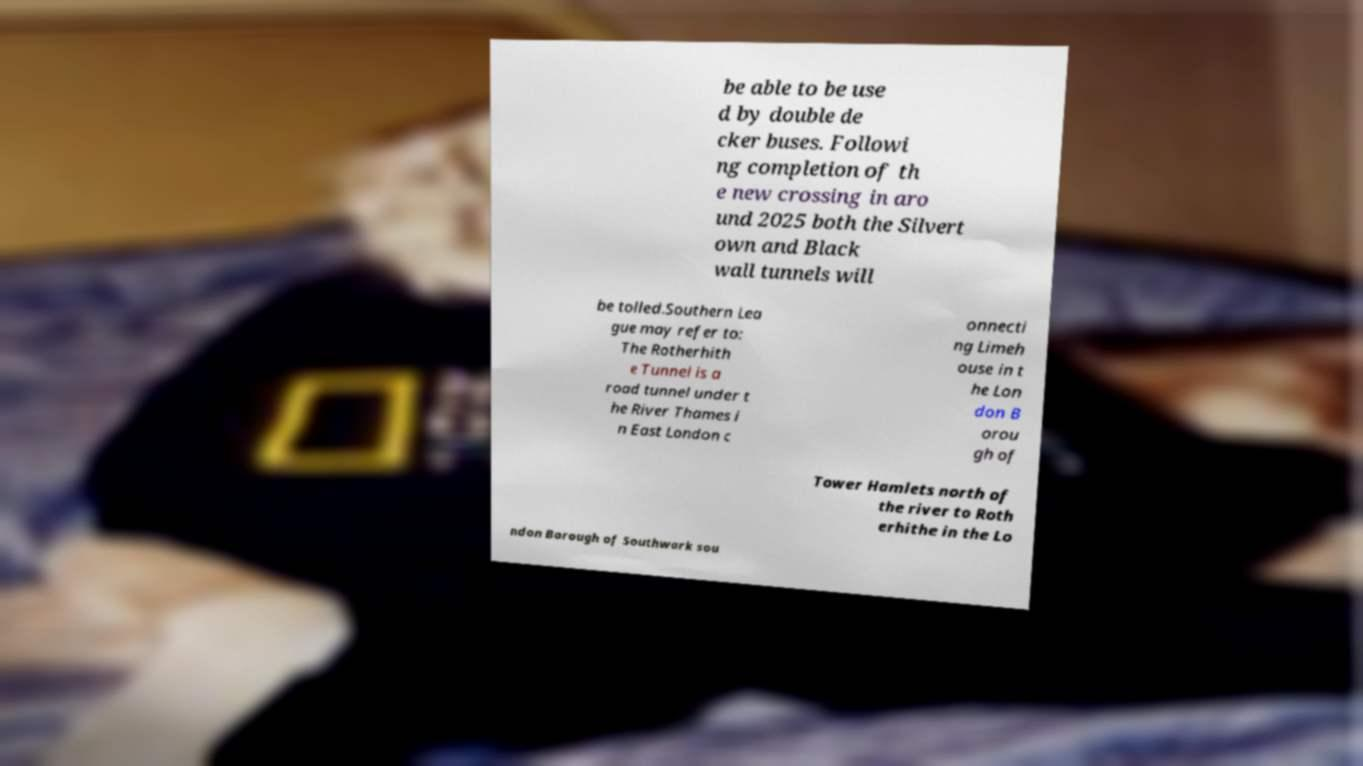Please read and relay the text visible in this image. What does it say? be able to be use d by double de cker buses. Followi ng completion of th e new crossing in aro und 2025 both the Silvert own and Black wall tunnels will be tolled.Southern Lea gue may refer to: The Rotherhith e Tunnel is a road tunnel under t he River Thames i n East London c onnecti ng Limeh ouse in t he Lon don B orou gh of Tower Hamlets north of the river to Roth erhithe in the Lo ndon Borough of Southwark sou 